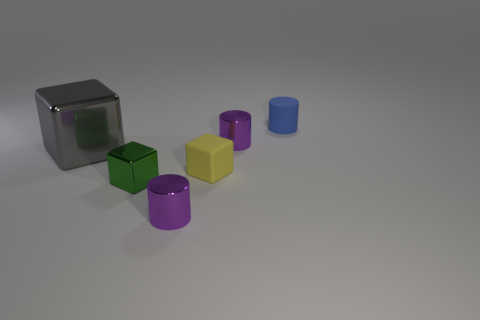Subtract all purple cylinders. How many cylinders are left? 1 Subtract all cyan spheres. How many purple cylinders are left? 2 Add 3 small green metal things. How many objects exist? 9 Subtract all purple cylinders. Subtract all blue balls. How many cylinders are left? 1 Subtract all purple objects. Subtract all big things. How many objects are left? 3 Add 1 matte blocks. How many matte blocks are left? 2 Add 4 blue rubber objects. How many blue rubber objects exist? 5 Subtract 0 cyan blocks. How many objects are left? 6 